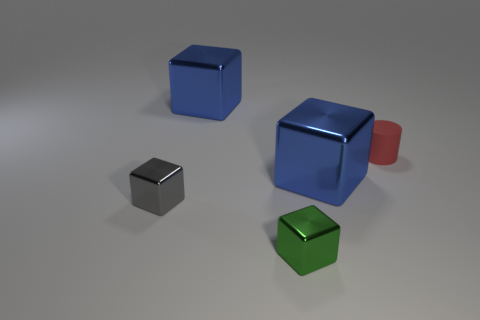Add 4 cylinders. How many objects exist? 9 Subtract all cylinders. How many objects are left? 4 Add 5 small gray metallic cubes. How many small gray metallic cubes are left? 6 Add 4 tiny cyan shiny cylinders. How many tiny cyan shiny cylinders exist? 4 Subtract 1 blue cubes. How many objects are left? 4 Subtract all tiny metallic blocks. Subtract all things. How many objects are left? 1 